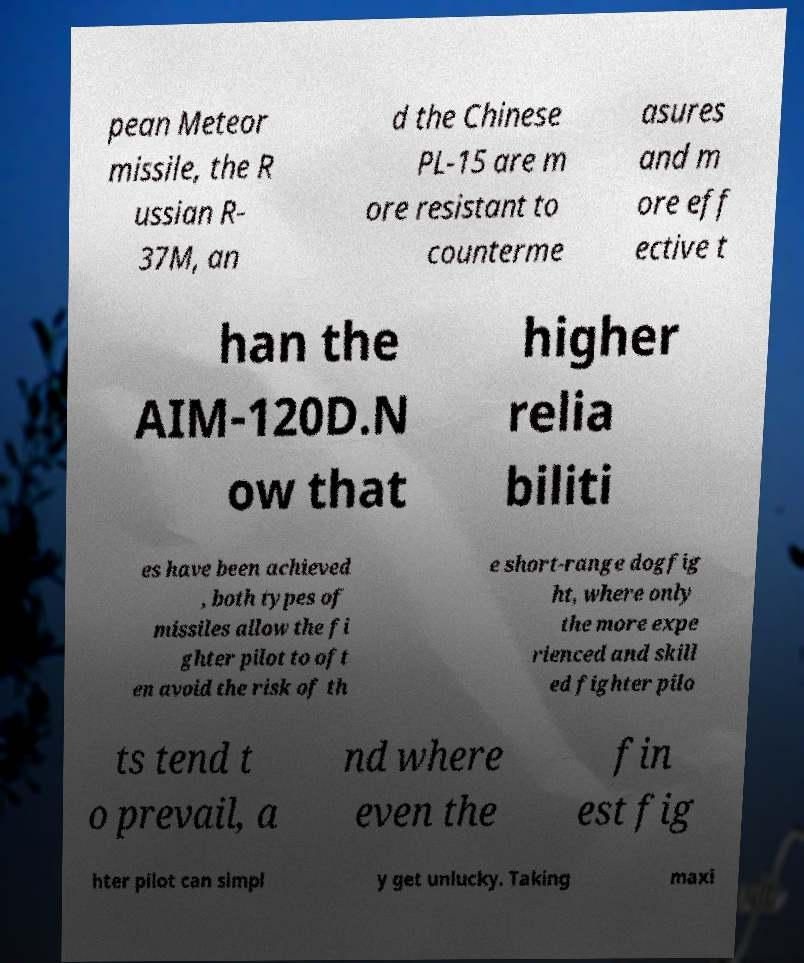Please identify and transcribe the text found in this image. pean Meteor missile, the R ussian R- 37M, an d the Chinese PL-15 are m ore resistant to counterme asures and m ore eff ective t han the AIM-120D.N ow that higher relia biliti es have been achieved , both types of missiles allow the fi ghter pilot to oft en avoid the risk of th e short-range dogfig ht, where only the more expe rienced and skill ed fighter pilo ts tend t o prevail, a nd where even the fin est fig hter pilot can simpl y get unlucky. Taking maxi 